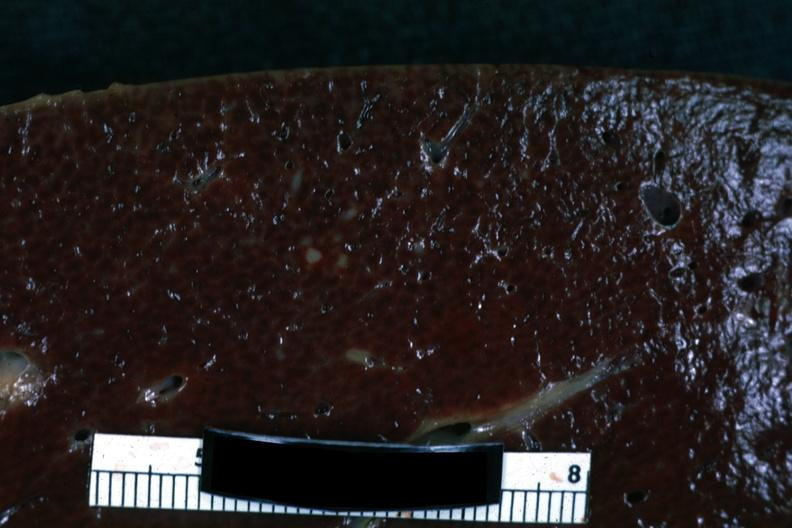does this image show cut surface with focal infiltrate?
Answer the question using a single word or phrase. Yes 